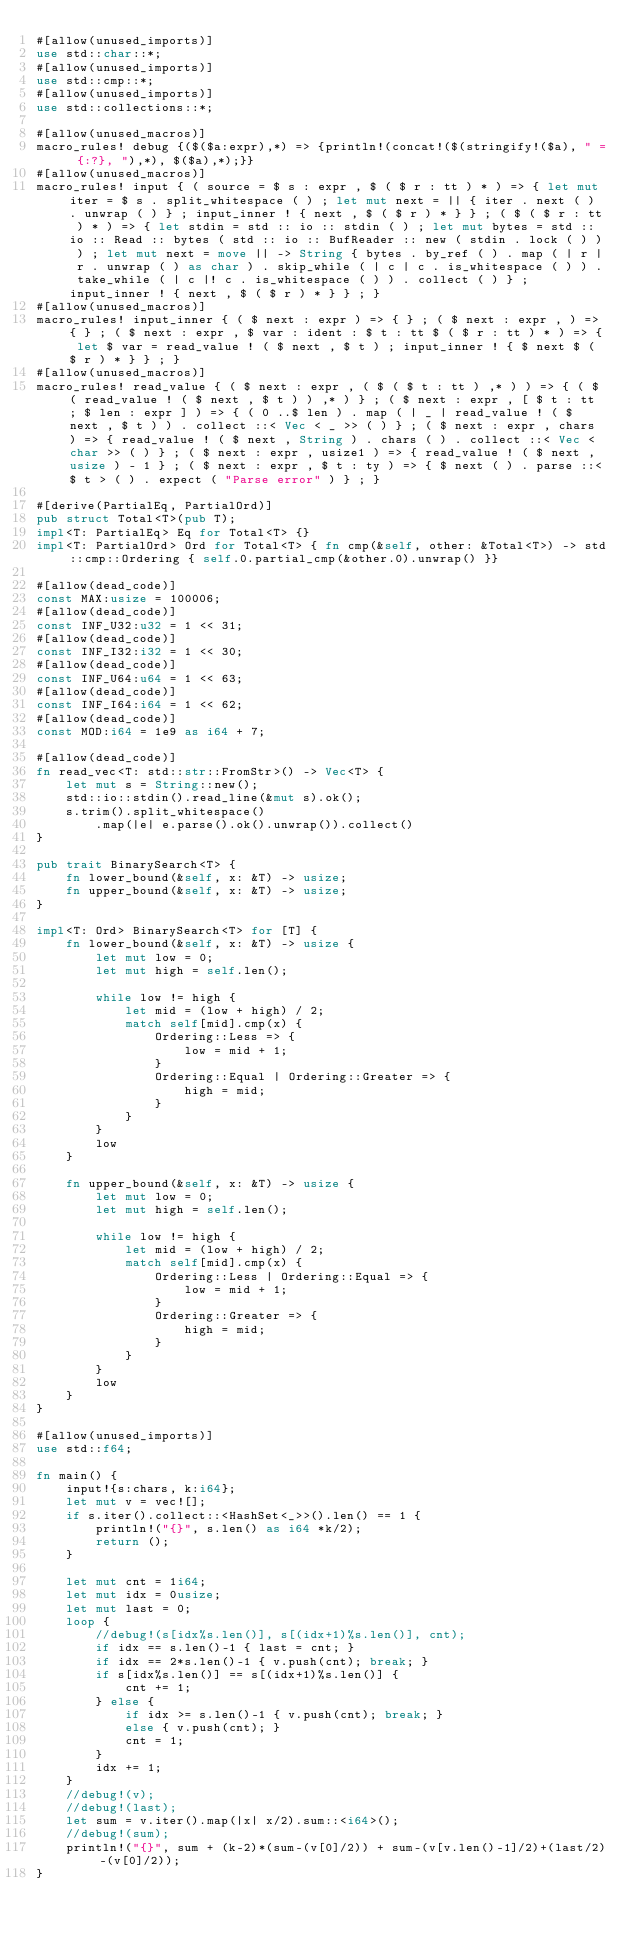Convert code to text. <code><loc_0><loc_0><loc_500><loc_500><_Rust_>#[allow(unused_imports)]
use std::char::*;
#[allow(unused_imports)]
use std::cmp::*;
#[allow(unused_imports)]
use std::collections::*;

#[allow(unused_macros)]
macro_rules! debug {($($a:expr),*) => {println!(concat!($(stringify!($a), " = {:?}, "),*), $($a),*);}}
#[allow(unused_macros)]
macro_rules! input { ( source = $ s : expr , $ ( $ r : tt ) * ) => { let mut iter = $ s . split_whitespace ( ) ; let mut next = || { iter . next ( ) . unwrap ( ) } ; input_inner ! { next , $ ( $ r ) * } } ; ( $ ( $ r : tt ) * ) => { let stdin = std :: io :: stdin ( ) ; let mut bytes = std :: io :: Read :: bytes ( std :: io :: BufReader :: new ( stdin . lock ( ) ) ) ; let mut next = move || -> String { bytes . by_ref ( ) . map ( | r | r . unwrap ( ) as char ) . skip_while ( | c | c . is_whitespace ( ) ) . take_while ( | c |! c . is_whitespace ( ) ) . collect ( ) } ; input_inner ! { next , $ ( $ r ) * } } ; }
#[allow(unused_macros)]
macro_rules! input_inner { ( $ next : expr ) => { } ; ( $ next : expr , ) => { } ; ( $ next : expr , $ var : ident : $ t : tt $ ( $ r : tt ) * ) => { let $ var = read_value ! ( $ next , $ t ) ; input_inner ! { $ next $ ( $ r ) * } } ; }
#[allow(unused_macros)]
macro_rules! read_value { ( $ next : expr , ( $ ( $ t : tt ) ,* ) ) => { ( $ ( read_value ! ( $ next , $ t ) ) ,* ) } ; ( $ next : expr , [ $ t : tt ; $ len : expr ] ) => { ( 0 ..$ len ) . map ( | _ | read_value ! ( $ next , $ t ) ) . collect ::< Vec < _ >> ( ) } ; ( $ next : expr , chars ) => { read_value ! ( $ next , String ) . chars ( ) . collect ::< Vec < char >> ( ) } ; ( $ next : expr , usize1 ) => { read_value ! ( $ next , usize ) - 1 } ; ( $ next : expr , $ t : ty ) => { $ next ( ) . parse ::<$ t > ( ) . expect ( "Parse error" ) } ; }

#[derive(PartialEq, PartialOrd)]
pub struct Total<T>(pub T);
impl<T: PartialEq> Eq for Total<T> {}
impl<T: PartialOrd> Ord for Total<T> { fn cmp(&self, other: &Total<T>) -> std::cmp::Ordering { self.0.partial_cmp(&other.0).unwrap() }}

#[allow(dead_code)]
const MAX:usize = 100006;
#[allow(dead_code)]
const INF_U32:u32 = 1 << 31;
#[allow(dead_code)]
const INF_I32:i32 = 1 << 30;
#[allow(dead_code)]
const INF_U64:u64 = 1 << 63;
#[allow(dead_code)]
const INF_I64:i64 = 1 << 62;
#[allow(dead_code)]
const MOD:i64 = 1e9 as i64 + 7;

#[allow(dead_code)]
fn read_vec<T: std::str::FromStr>() -> Vec<T> {
    let mut s = String::new();
    std::io::stdin().read_line(&mut s).ok();
    s.trim().split_whitespace()
        .map(|e| e.parse().ok().unwrap()).collect()
}

pub trait BinarySearch<T> {
    fn lower_bound(&self, x: &T) -> usize;
    fn upper_bound(&self, x: &T) -> usize;
}

impl<T: Ord> BinarySearch<T> for [T] {
    fn lower_bound(&self, x: &T) -> usize {
        let mut low = 0;
        let mut high = self.len();

        while low != high {
            let mid = (low + high) / 2;
            match self[mid].cmp(x) {
                Ordering::Less => {
                    low = mid + 1;
                }
                Ordering::Equal | Ordering::Greater => {
                    high = mid;
                }
            }
        }
        low
    }

    fn upper_bound(&self, x: &T) -> usize {
        let mut low = 0;
        let mut high = self.len();

        while low != high {
            let mid = (low + high) / 2;
            match self[mid].cmp(x) {
                Ordering::Less | Ordering::Equal => {
                    low = mid + 1;
                }
                Ordering::Greater => {
                    high = mid;
                }
            }
        }
        low
    }
}

#[allow(unused_imports)]
use std::f64;

fn main() {
    input!{s:chars, k:i64};
    let mut v = vec![];
    if s.iter().collect::<HashSet<_>>().len() == 1 {
        println!("{}", s.len() as i64 *k/2);
        return ();
    }

    let mut cnt = 1i64;
    let mut idx = 0usize;
    let mut last = 0;
    loop {
        //debug!(s[idx%s.len()], s[(idx+1)%s.len()], cnt);
        if idx == s.len()-1 { last = cnt; }
        if idx == 2*s.len()-1 { v.push(cnt); break; }
        if s[idx%s.len()] == s[(idx+1)%s.len()] {
            cnt += 1;
        } else {
            if idx >= s.len()-1 { v.push(cnt); break; }
            else { v.push(cnt); }
            cnt = 1;
        }
        idx += 1;
    }
    //debug!(v);
    //debug!(last);
    let sum = v.iter().map(|x| x/2).sum::<i64>();
    //debug!(sum);
    println!("{}", sum + (k-2)*(sum-(v[0]/2)) + sum-(v[v.len()-1]/2)+(last/2)-(v[0]/2));
}</code> 